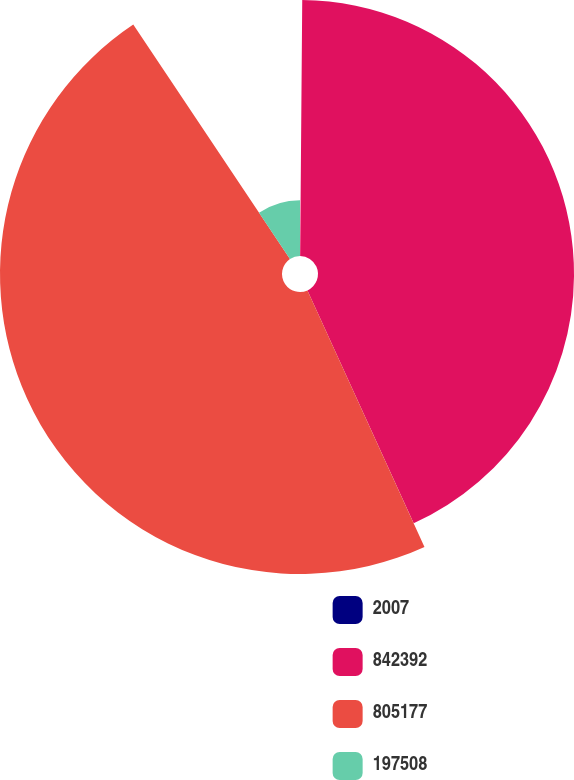Convert chart to OTSL. <chart><loc_0><loc_0><loc_500><loc_500><pie_chart><fcel>2007<fcel>842392<fcel>805177<fcel>197508<nl><fcel>0.13%<fcel>43.06%<fcel>47.43%<fcel>9.38%<nl></chart> 